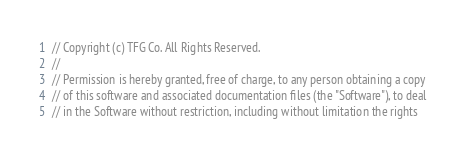Convert code to text. <code><loc_0><loc_0><loc_500><loc_500><_Go_>// Copyright (c) TFG Co. All Rights Reserved.
//
// Permission is hereby granted, free of charge, to any person obtaining a copy
// of this software and associated documentation files (the "Software"), to deal
// in the Software without restriction, including without limitation the rights</code> 